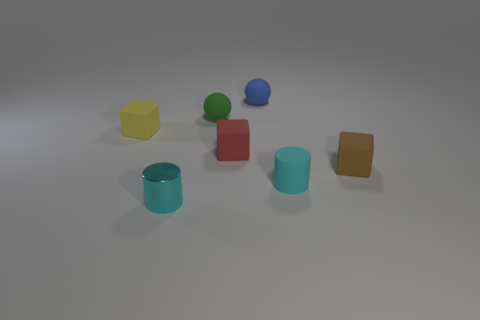There is a tiny cyan thing in front of the tiny cyan cylinder right of the tiny blue object; what is its shape?
Provide a succinct answer. Cylinder. There is a thing that is both left of the green sphere and behind the cyan metallic cylinder; what is its size?
Give a very brief answer. Small. Is there a cyan rubber thing of the same shape as the tiny cyan metal thing?
Give a very brief answer. Yes. Is there anything else that has the same shape as the small cyan shiny thing?
Your answer should be very brief. Yes. The cyan cylinder right of the tiny cyan metal cylinder on the left side of the rubber thing in front of the tiny brown object is made of what material?
Offer a very short reply. Rubber. Are there any green things of the same size as the blue rubber thing?
Offer a very short reply. Yes. What is the color of the cube that is right of the small blue object that is right of the tiny cyan metallic cylinder?
Your response must be concise. Brown. How many brown shiny cubes are there?
Offer a very short reply. 0. Is the rubber cylinder the same color as the tiny metal cylinder?
Offer a very short reply. Yes. Is the number of red matte objects that are behind the green object less than the number of brown rubber cubes in front of the cyan rubber cylinder?
Your answer should be very brief. No. 